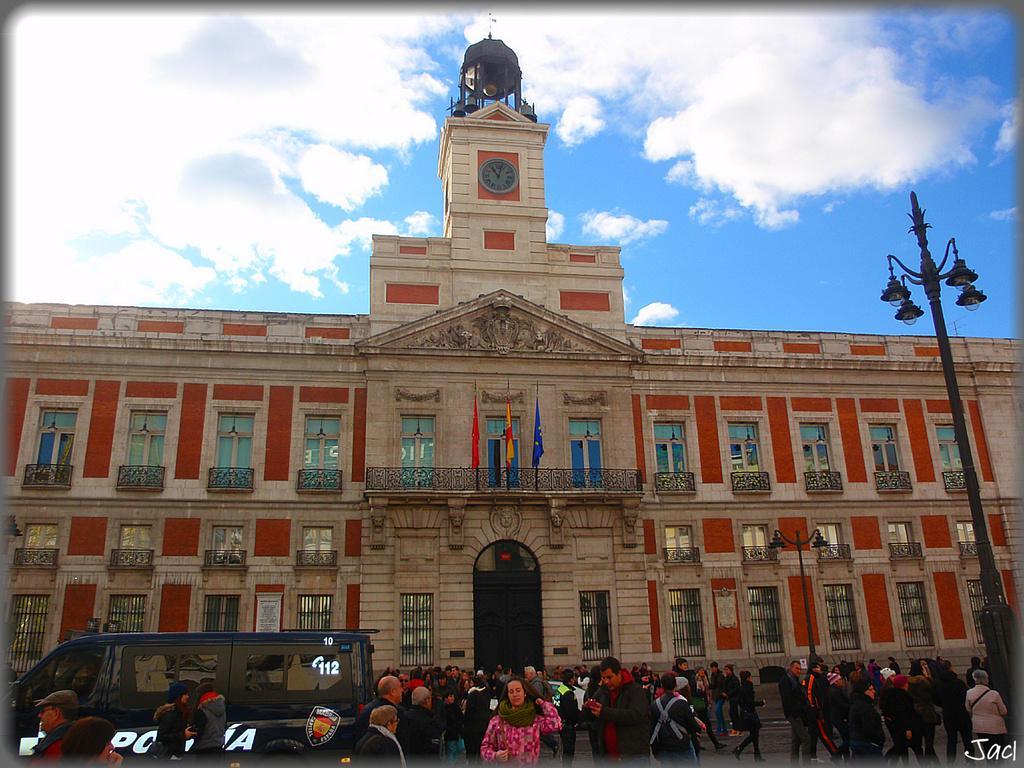Please provide a concise description of this image. In this image I can see a building which has flags on it. Here I can see people and vehicle. On the right side I can see a street light. In the background I can see the sky. Here I can see a watermark. 